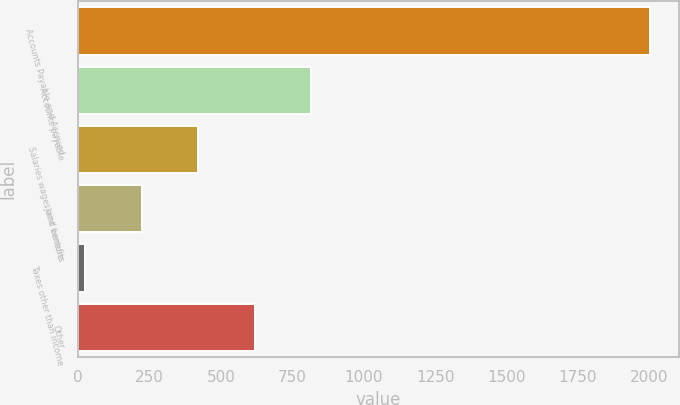Convert chart. <chart><loc_0><loc_0><loc_500><loc_500><bar_chart><fcel>Accounts Payable and Accrued<fcel>Accounts payable<fcel>Salaries wages and benefits<fcel>Joint venture<fcel>Taxes other than income<fcel>Other<nl><fcel>2003<fcel>815.48<fcel>419.64<fcel>221.72<fcel>23.8<fcel>617.56<nl></chart> 